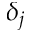Convert formula to latex. <formula><loc_0><loc_0><loc_500><loc_500>\delta _ { j }</formula> 